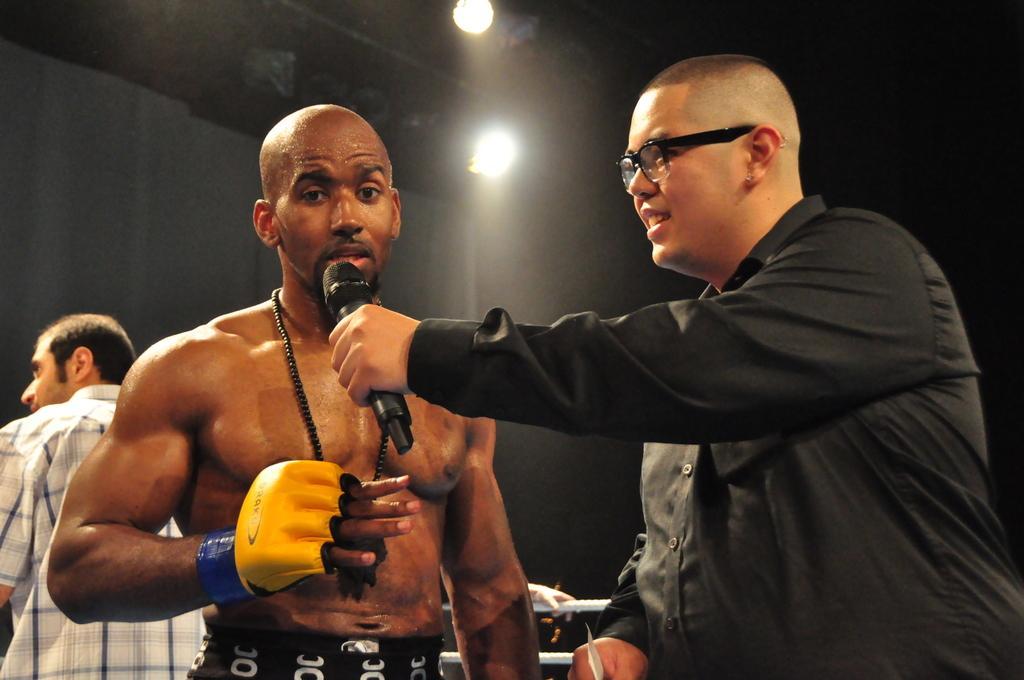How would you summarize this image in a sentence or two? In this image there are three men standing. The man to the right is holding a microphone in his hand. The man in the center is wearing boxing gloves. Behind him there is another man standing. Behind them there are ropes. The background is dark. At the top there are lights. 